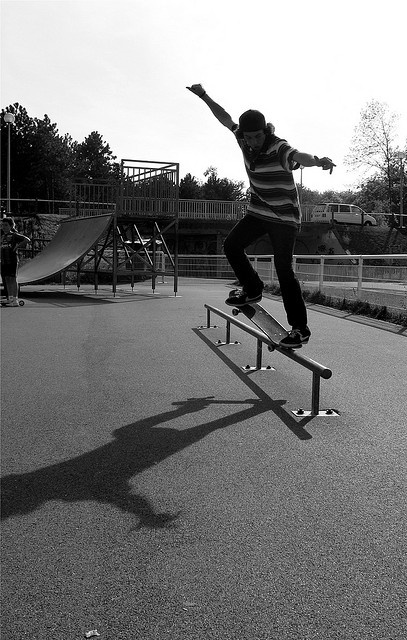Describe the objects in this image and their specific colors. I can see people in white, black, gray, whitesmoke, and darkgray tones, people in white, black, gray, darkgray, and lightgray tones, skateboard in white, gray, black, darkgray, and lightgray tones, and car in white, gray, black, darkgray, and lightgray tones in this image. 